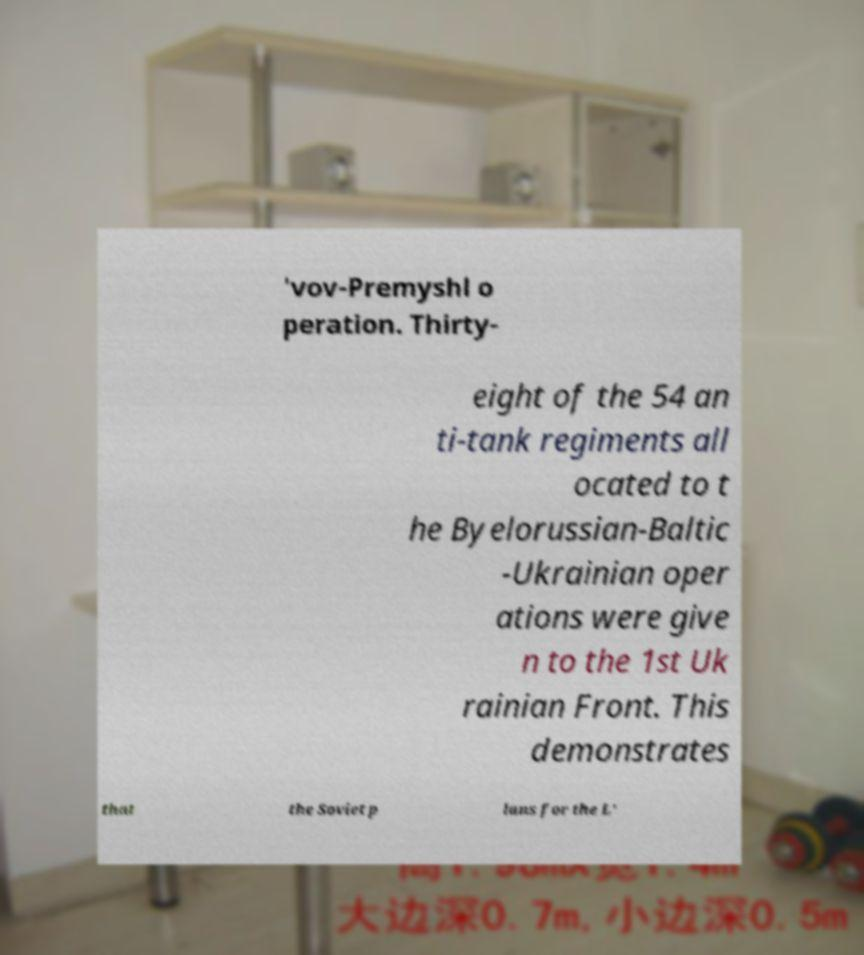Please identify and transcribe the text found in this image. 'vov-Premyshl o peration. Thirty- eight of the 54 an ti-tank regiments all ocated to t he Byelorussian-Baltic -Ukrainian oper ations were give n to the 1st Uk rainian Front. This demonstrates that the Soviet p lans for the L' 